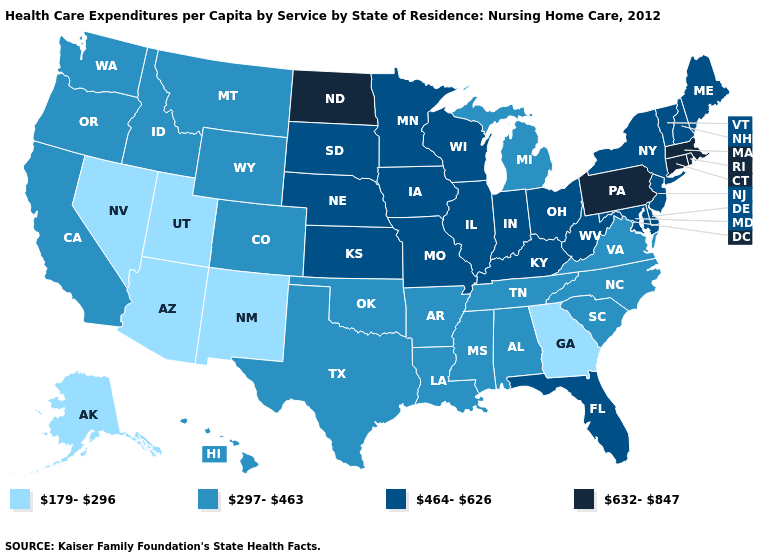What is the highest value in states that border South Dakota?
Be succinct. 632-847. How many symbols are there in the legend?
Be succinct. 4. Is the legend a continuous bar?
Concise answer only. No. What is the lowest value in the MidWest?
Be succinct. 297-463. What is the value of Hawaii?
Be succinct. 297-463. Does Nevada have the same value as Illinois?
Give a very brief answer. No. Does Mississippi have a higher value than Virginia?
Short answer required. No. What is the highest value in the MidWest ?
Short answer required. 632-847. Name the states that have a value in the range 297-463?
Short answer required. Alabama, Arkansas, California, Colorado, Hawaii, Idaho, Louisiana, Michigan, Mississippi, Montana, North Carolina, Oklahoma, Oregon, South Carolina, Tennessee, Texas, Virginia, Washington, Wyoming. Does the first symbol in the legend represent the smallest category?
Be succinct. Yes. What is the value of Oklahoma?
Be succinct. 297-463. Does the map have missing data?
Give a very brief answer. No. Name the states that have a value in the range 297-463?
Be succinct. Alabama, Arkansas, California, Colorado, Hawaii, Idaho, Louisiana, Michigan, Mississippi, Montana, North Carolina, Oklahoma, Oregon, South Carolina, Tennessee, Texas, Virginia, Washington, Wyoming. Does Kentucky have a lower value than Pennsylvania?
Keep it brief. Yes. What is the highest value in the USA?
Concise answer only. 632-847. 